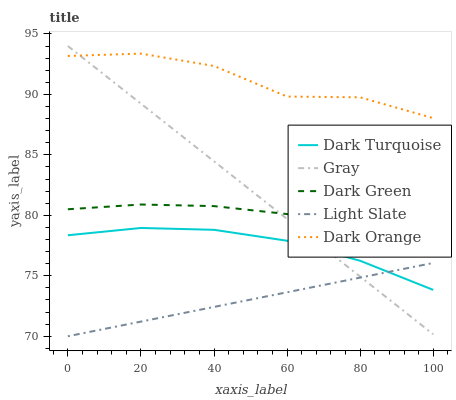Does Light Slate have the minimum area under the curve?
Answer yes or no. Yes. Does Dark Orange have the maximum area under the curve?
Answer yes or no. Yes. Does Dark Turquoise have the minimum area under the curve?
Answer yes or no. No. Does Dark Turquoise have the maximum area under the curve?
Answer yes or no. No. Is Gray the smoothest?
Answer yes or no. Yes. Is Dark Orange the roughest?
Answer yes or no. Yes. Is Dark Turquoise the smoothest?
Answer yes or no. No. Is Dark Turquoise the roughest?
Answer yes or no. No. Does Light Slate have the lowest value?
Answer yes or no. Yes. Does Dark Turquoise have the lowest value?
Answer yes or no. No. Does Gray have the highest value?
Answer yes or no. Yes. Does Dark Turquoise have the highest value?
Answer yes or no. No. Is Dark Turquoise less than Dark Green?
Answer yes or no. Yes. Is Dark Orange greater than Dark Green?
Answer yes or no. Yes. Does Gray intersect Dark Orange?
Answer yes or no. Yes. Is Gray less than Dark Orange?
Answer yes or no. No. Is Gray greater than Dark Orange?
Answer yes or no. No. Does Dark Turquoise intersect Dark Green?
Answer yes or no. No. 